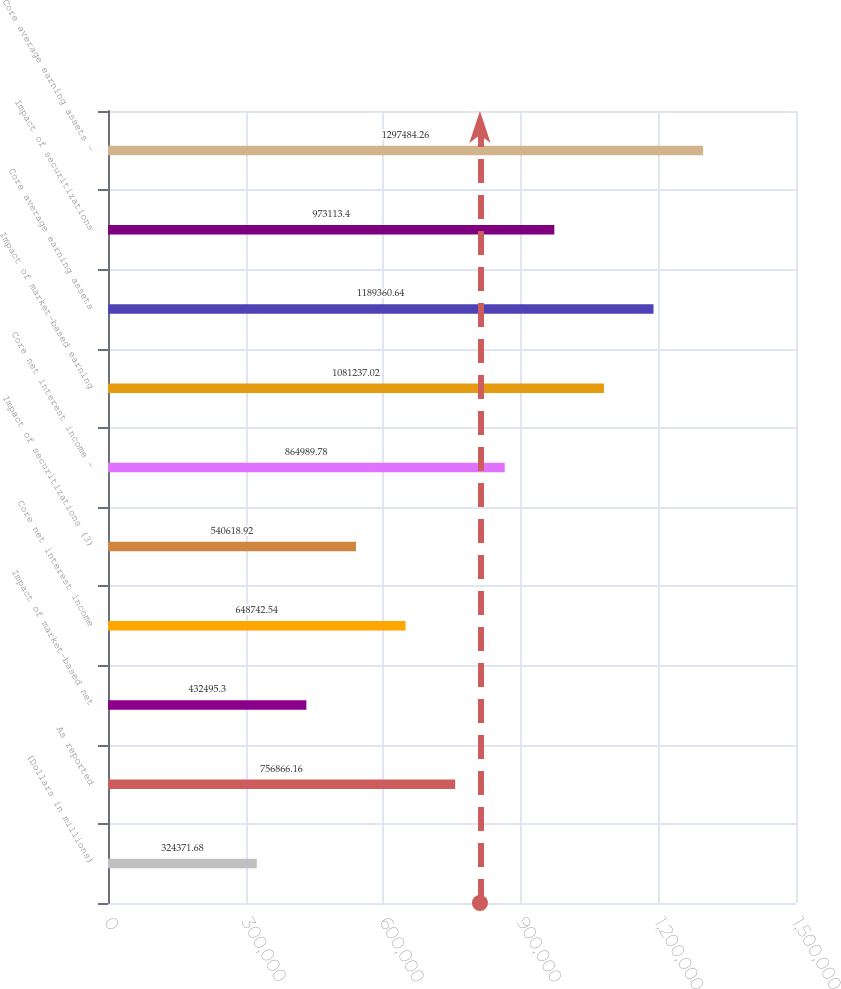<chart> <loc_0><loc_0><loc_500><loc_500><bar_chart><fcel>(Dollars in millions)<fcel>As reported<fcel>Impact of market-based net<fcel>Core net interest income<fcel>Impact of securitizations (3)<fcel>Core net interest income -<fcel>Impact of market-based earning<fcel>Core average earning assets<fcel>Impact of securitizations<fcel>Core average earning assets -<nl><fcel>324372<fcel>756866<fcel>432495<fcel>648743<fcel>540619<fcel>864990<fcel>1.08124e+06<fcel>1.18936e+06<fcel>973113<fcel>1.29748e+06<nl></chart> 